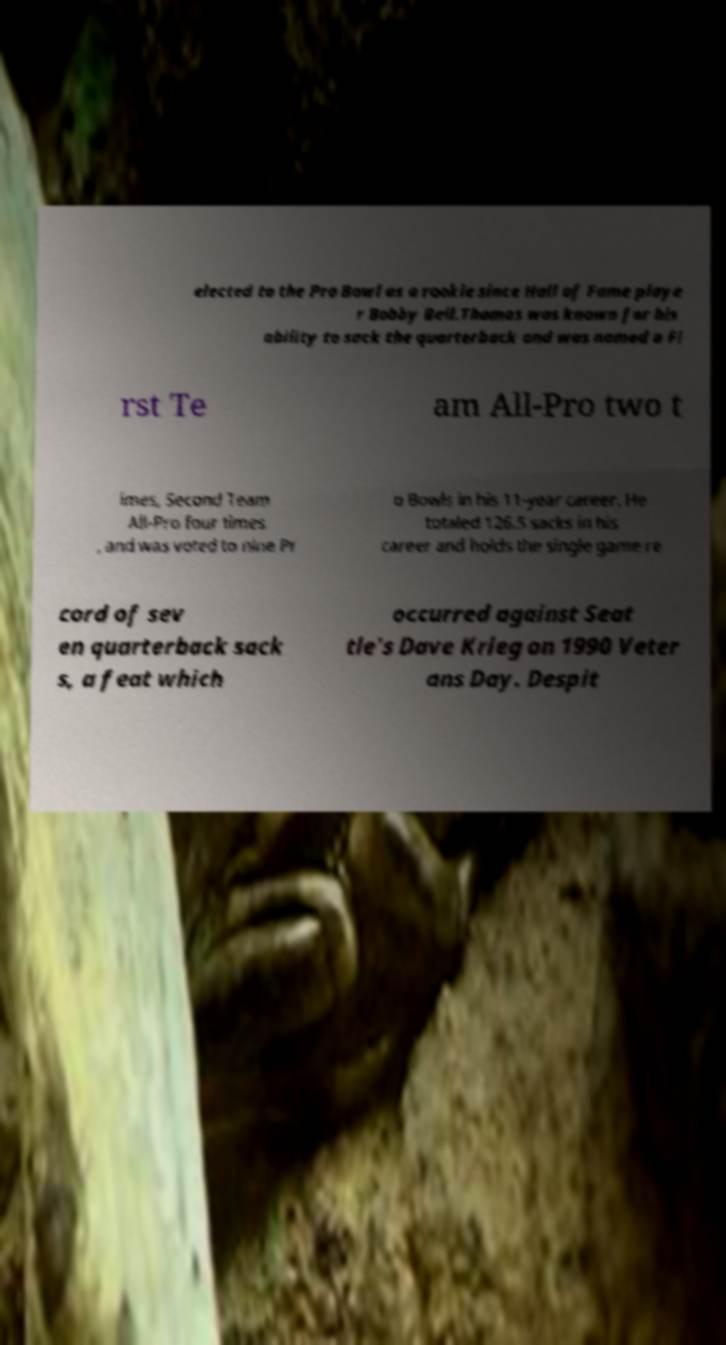Could you extract and type out the text from this image? elected to the Pro Bowl as a rookie since Hall of Fame playe r Bobby Bell.Thomas was known for his ability to sack the quarterback and was named a Fi rst Te am All-Pro two t imes, Second Team All-Pro four times , and was voted to nine Pr o Bowls in his 11-year career. He totaled 126.5 sacks in his career and holds the single game re cord of sev en quarterback sack s, a feat which occurred against Seat tle's Dave Krieg on 1990 Veter ans Day. Despit 